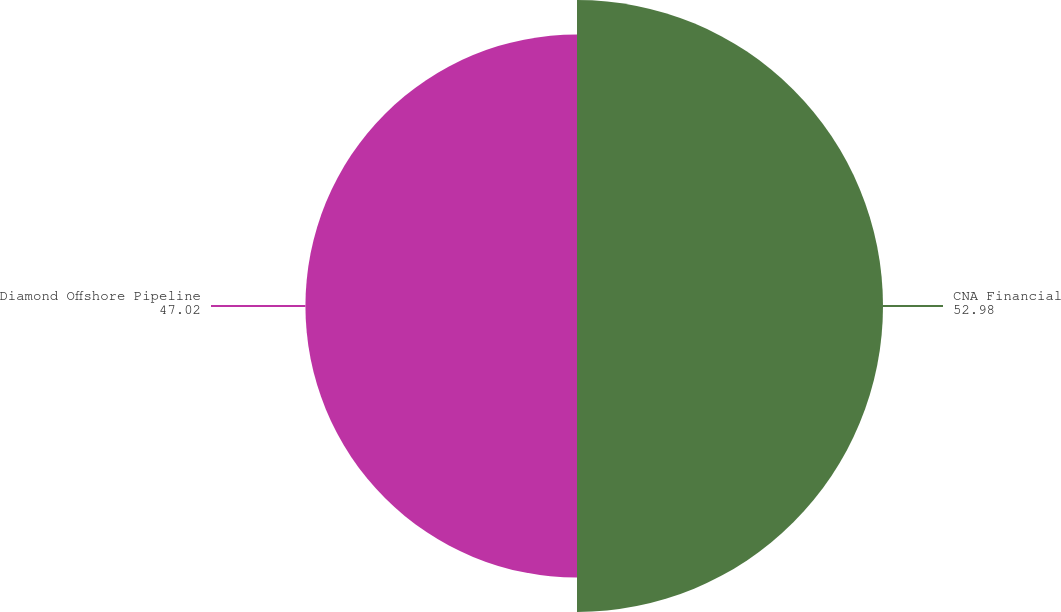<chart> <loc_0><loc_0><loc_500><loc_500><pie_chart><fcel>CNA Financial<fcel>Diamond Offshore Pipeline<nl><fcel>52.98%<fcel>47.02%<nl></chart> 